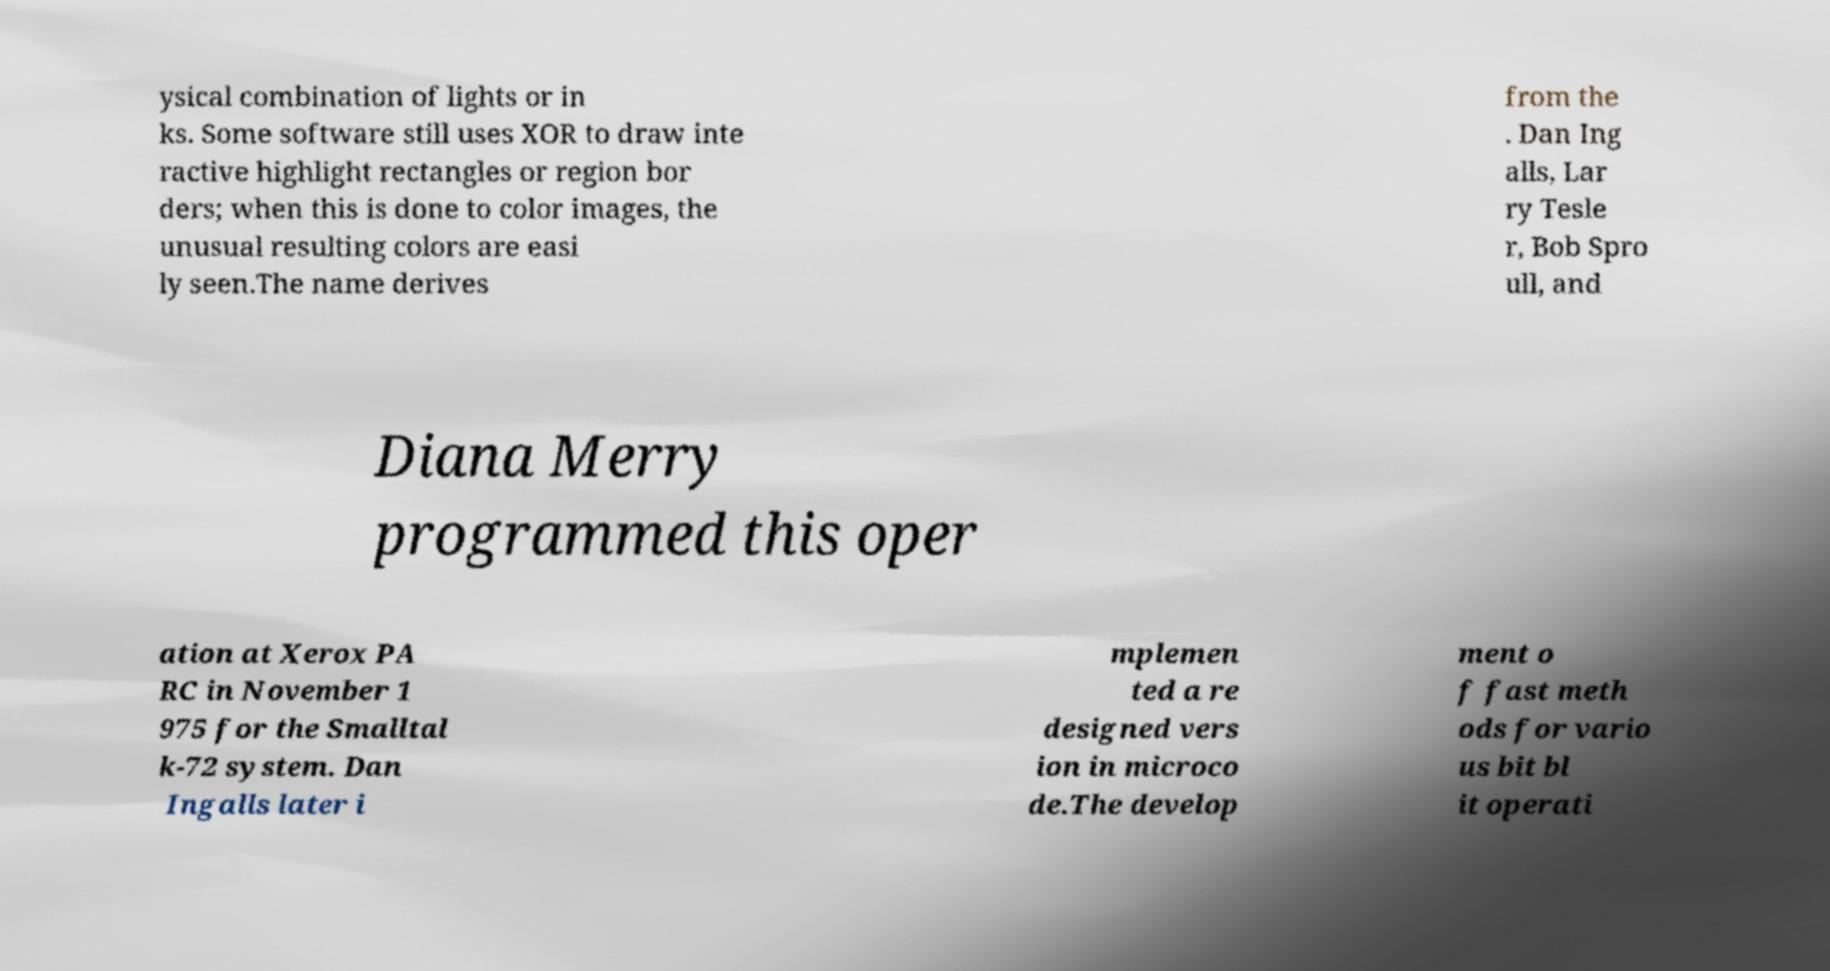Please read and relay the text visible in this image. What does it say? ysical combination of lights or in ks. Some software still uses XOR to draw inte ractive highlight rectangles or region bor ders; when this is done to color images, the unusual resulting colors are easi ly seen.The name derives from the . Dan Ing alls, Lar ry Tesle r, Bob Spro ull, and Diana Merry programmed this oper ation at Xerox PA RC in November 1 975 for the Smalltal k-72 system. Dan Ingalls later i mplemen ted a re designed vers ion in microco de.The develop ment o f fast meth ods for vario us bit bl it operati 